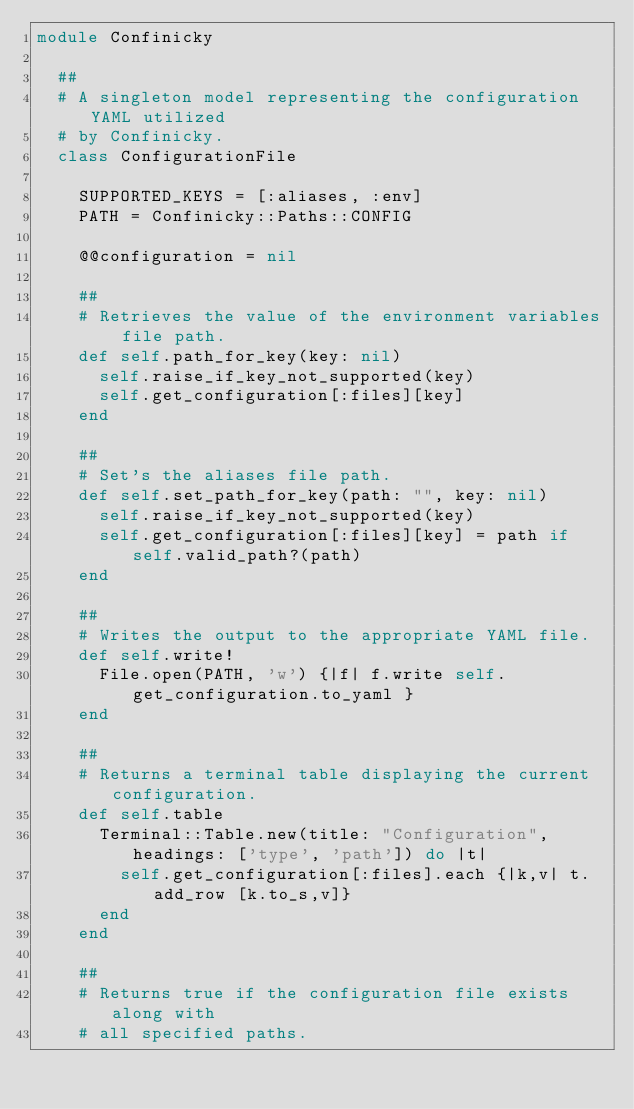<code> <loc_0><loc_0><loc_500><loc_500><_Ruby_>module Confinicky

  ##
  # A singleton model representing the configuration YAML utilized
  # by Confinicky.
  class ConfigurationFile

    SUPPORTED_KEYS = [:aliases, :env]
    PATH = Confinicky::Paths::CONFIG

    @@configuration = nil

    ##
    # Retrieves the value of the environment variables file path.
    def self.path_for_key(key: nil)
      self.raise_if_key_not_supported(key)
      self.get_configuration[:files][key]
    end

    ##
    # Set's the aliases file path.
    def self.set_path_for_key(path: "", key: nil)
      self.raise_if_key_not_supported(key)
      self.get_configuration[:files][key] = path if self.valid_path?(path)
    end

    ##
    # Writes the output to the appropriate YAML file.
    def self.write!
      File.open(PATH, 'w') {|f| f.write self.get_configuration.to_yaml }
    end

    ##
    # Returns a terminal table displaying the current configuration.
    def self.table
      Terminal::Table.new(title: "Configuration", headings: ['type', 'path']) do |t|
        self.get_configuration[:files].each {|k,v| t.add_row [k.to_s,v]}
      end
    end

    ##
    # Returns true if the configuration file exists along with
    # all specified paths.</code> 